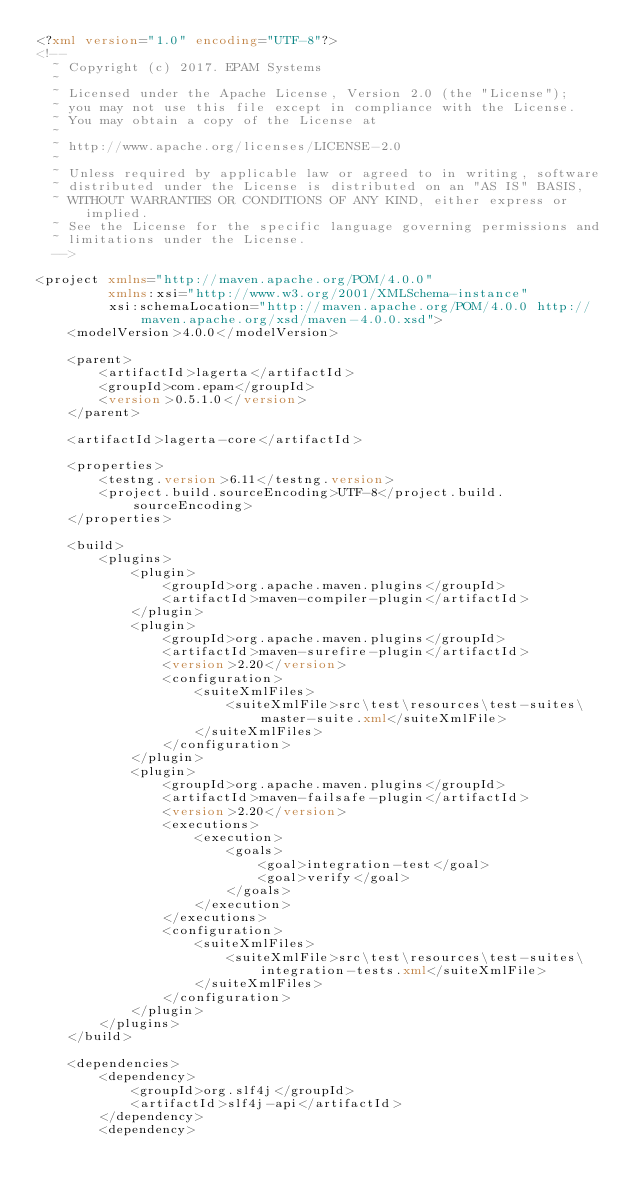<code> <loc_0><loc_0><loc_500><loc_500><_XML_><?xml version="1.0" encoding="UTF-8"?>
<!--
  ~ Copyright (c) 2017. EPAM Systems
  ~
  ~ Licensed under the Apache License, Version 2.0 (the "License");
  ~ you may not use this file except in compliance with the License.
  ~ You may obtain a copy of the License at
  ~
  ~ http://www.apache.org/licenses/LICENSE-2.0
  ~
  ~ Unless required by applicable law or agreed to in writing, software
  ~ distributed under the License is distributed on an "AS IS" BASIS,
  ~ WITHOUT WARRANTIES OR CONDITIONS OF ANY KIND, either express or implied.
  ~ See the License for the specific language governing permissions and
  ~ limitations under the License.
  -->

<project xmlns="http://maven.apache.org/POM/4.0.0"
         xmlns:xsi="http://www.w3.org/2001/XMLSchema-instance"
         xsi:schemaLocation="http://maven.apache.org/POM/4.0.0 http://maven.apache.org/xsd/maven-4.0.0.xsd">
    <modelVersion>4.0.0</modelVersion>

    <parent>
        <artifactId>lagerta</artifactId>
        <groupId>com.epam</groupId>
        <version>0.5.1.0</version>
    </parent>

    <artifactId>lagerta-core</artifactId>

    <properties>
        <testng.version>6.11</testng.version>
        <project.build.sourceEncoding>UTF-8</project.build.sourceEncoding>
    </properties>

    <build>
        <plugins>
            <plugin>
                <groupId>org.apache.maven.plugins</groupId>
                <artifactId>maven-compiler-plugin</artifactId>
            </plugin>
            <plugin>
                <groupId>org.apache.maven.plugins</groupId>
                <artifactId>maven-surefire-plugin</artifactId>
                <version>2.20</version>
                <configuration>
                    <suiteXmlFiles>
                        <suiteXmlFile>src\test\resources\test-suites\master-suite.xml</suiteXmlFile>
                    </suiteXmlFiles>
                </configuration>
            </plugin>
            <plugin>
                <groupId>org.apache.maven.plugins</groupId>
                <artifactId>maven-failsafe-plugin</artifactId>
                <version>2.20</version>
                <executions>
                    <execution>
                        <goals>
                            <goal>integration-test</goal>
                            <goal>verify</goal>
                        </goals>
                    </execution>
                </executions>
                <configuration>
                    <suiteXmlFiles>
                        <suiteXmlFile>src\test\resources\test-suites\integration-tests.xml</suiteXmlFile>
                    </suiteXmlFiles>
                </configuration>
            </plugin>
        </plugins>
    </build>

    <dependencies>
        <dependency>
            <groupId>org.slf4j</groupId>
            <artifactId>slf4j-api</artifactId>
        </dependency>
        <dependency></code> 